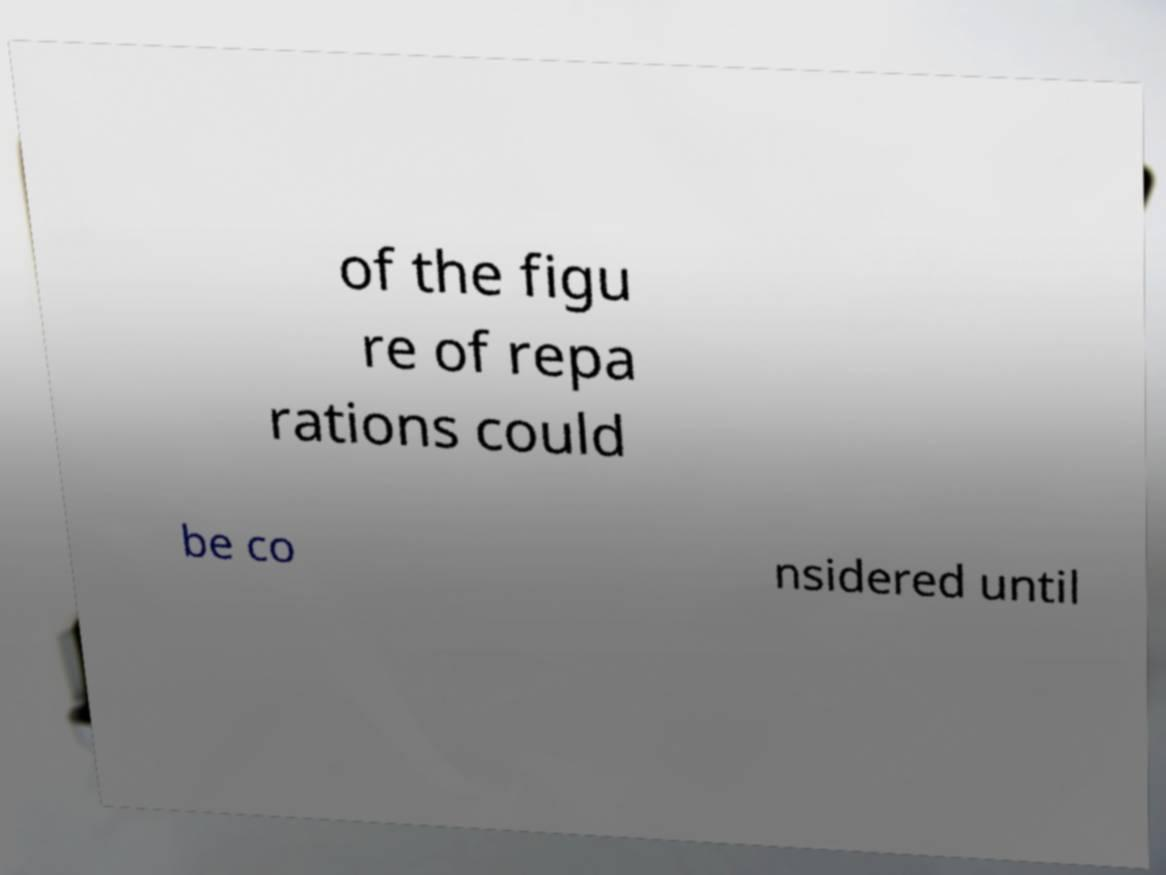Could you extract and type out the text from this image? of the figu re of repa rations could be co nsidered until 